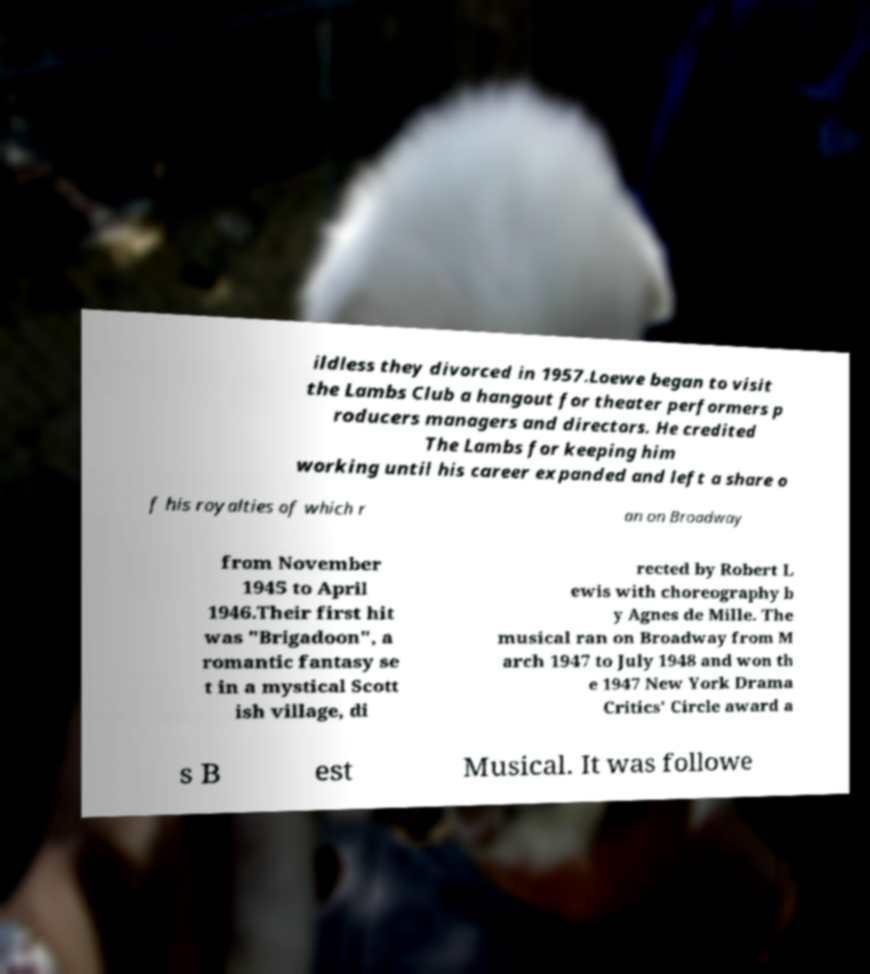Could you assist in decoding the text presented in this image and type it out clearly? ildless they divorced in 1957.Loewe began to visit the Lambs Club a hangout for theater performers p roducers managers and directors. He credited The Lambs for keeping him working until his career expanded and left a share o f his royalties of which r an on Broadway from November 1945 to April 1946.Their first hit was "Brigadoon", a romantic fantasy se t in a mystical Scott ish village, di rected by Robert L ewis with choreography b y Agnes de Mille. The musical ran on Broadway from M arch 1947 to July 1948 and won th e 1947 New York Drama Critics' Circle award a s B est Musical. It was followe 